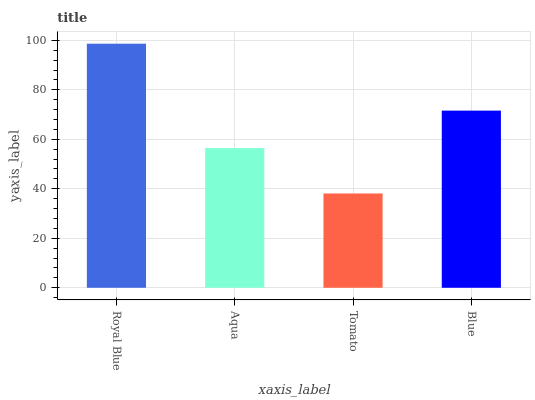Is Tomato the minimum?
Answer yes or no. Yes. Is Royal Blue the maximum?
Answer yes or no. Yes. Is Aqua the minimum?
Answer yes or no. No. Is Aqua the maximum?
Answer yes or no. No. Is Royal Blue greater than Aqua?
Answer yes or no. Yes. Is Aqua less than Royal Blue?
Answer yes or no. Yes. Is Aqua greater than Royal Blue?
Answer yes or no. No. Is Royal Blue less than Aqua?
Answer yes or no. No. Is Blue the high median?
Answer yes or no. Yes. Is Aqua the low median?
Answer yes or no. Yes. Is Aqua the high median?
Answer yes or no. No. Is Royal Blue the low median?
Answer yes or no. No. 